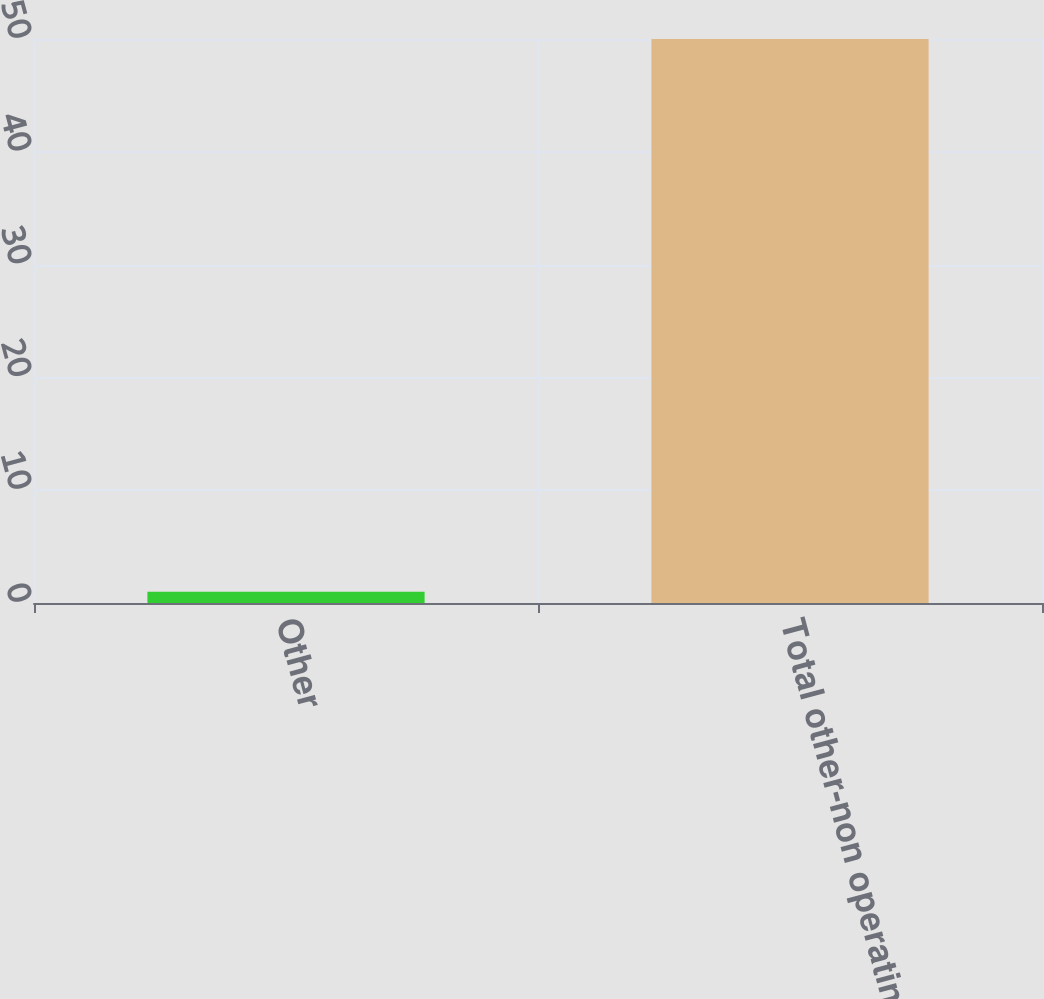<chart> <loc_0><loc_0><loc_500><loc_500><bar_chart><fcel>Other<fcel>Total other-non operating<nl><fcel>1<fcel>50<nl></chart> 